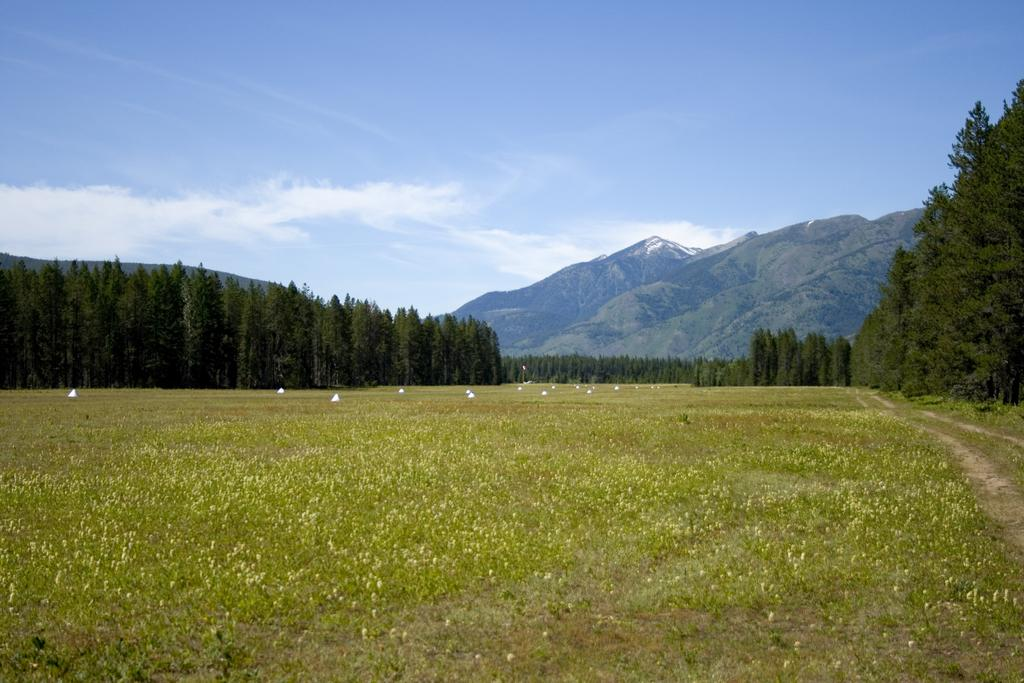What type of living organisms can be seen in the image? Plants and trees are visible in the image. What color are the objects in the image? The objects in the image are white. What is visible in the background of the image? There is a mountain and sky visible in the background of the image. What can be seen in the sky? Clouds are present in the sky. What type of liquid can be seen flowing from the calendar in the image? There is no calendar or liquid present in the image. Can you tell me the age of the grandfather in the image? There is no grandfather present in the image. 